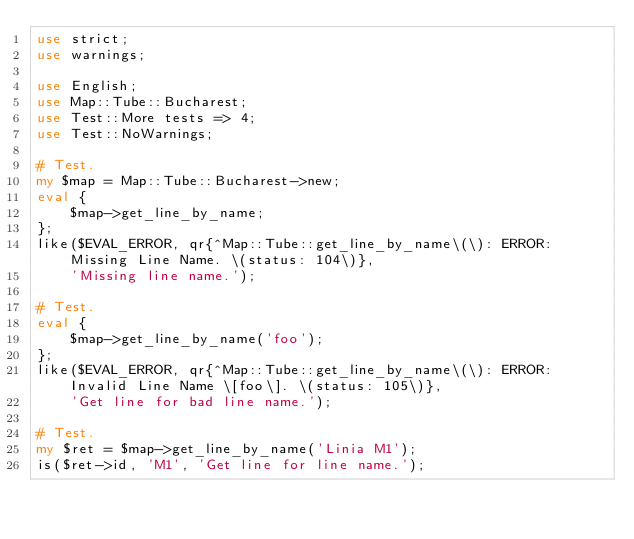<code> <loc_0><loc_0><loc_500><loc_500><_Perl_>use strict;
use warnings;

use English;
use Map::Tube::Bucharest;
use Test::More tests => 4;
use Test::NoWarnings;

# Test.
my $map = Map::Tube::Bucharest->new;
eval {
	$map->get_line_by_name;
};
like($EVAL_ERROR, qr{^Map::Tube::get_line_by_name\(\): ERROR: Missing Line Name. \(status: 104\)},
	'Missing line name.');

# Test.
eval {
	$map->get_line_by_name('foo');
};
like($EVAL_ERROR, qr{^Map::Tube::get_line_by_name\(\): ERROR: Invalid Line Name \[foo\]. \(status: 105\)},
	'Get line for bad line name.');

# Test.
my $ret = $map->get_line_by_name('Linia M1');
is($ret->id, 'M1', 'Get line for line name.');
</code> 